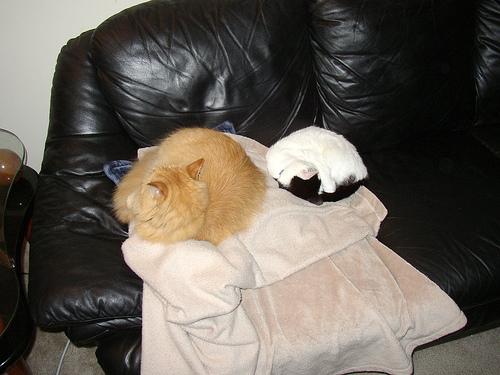Are both cats the same size?
Answer briefly. No. What is the couch made of?
Short answer required. Leather. What are the kids laying on?
Keep it brief. Blanket. 